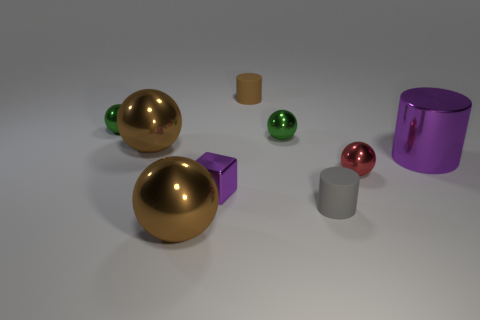There is a big object that is the same color as the tiny metal cube; what is its material?
Your answer should be compact. Metal. What is the shape of the large shiny thing that is on the left side of the big purple thing and behind the small gray matte object?
Offer a very short reply. Sphere. There is a purple object that is on the left side of the purple metal cylinder; what size is it?
Offer a very short reply. Small. Does the tiny metallic cube left of the gray object have the same color as the large cylinder?
Keep it short and to the point. Yes. How many brown things have the same shape as the large purple metallic object?
Provide a short and direct response. 1. What number of objects are either large things that are in front of the small cube or tiny shiny things on the left side of the gray object?
Keep it short and to the point. 4. What number of brown things are tiny rubber cylinders or large balls?
Provide a succinct answer. 3. There is a ball that is in front of the shiny cylinder and left of the gray cylinder; what material is it made of?
Make the answer very short. Metal. Are the red ball and the purple cylinder made of the same material?
Provide a short and direct response. Yes. How many brown spheres are the same size as the red shiny object?
Ensure brevity in your answer.  0. 